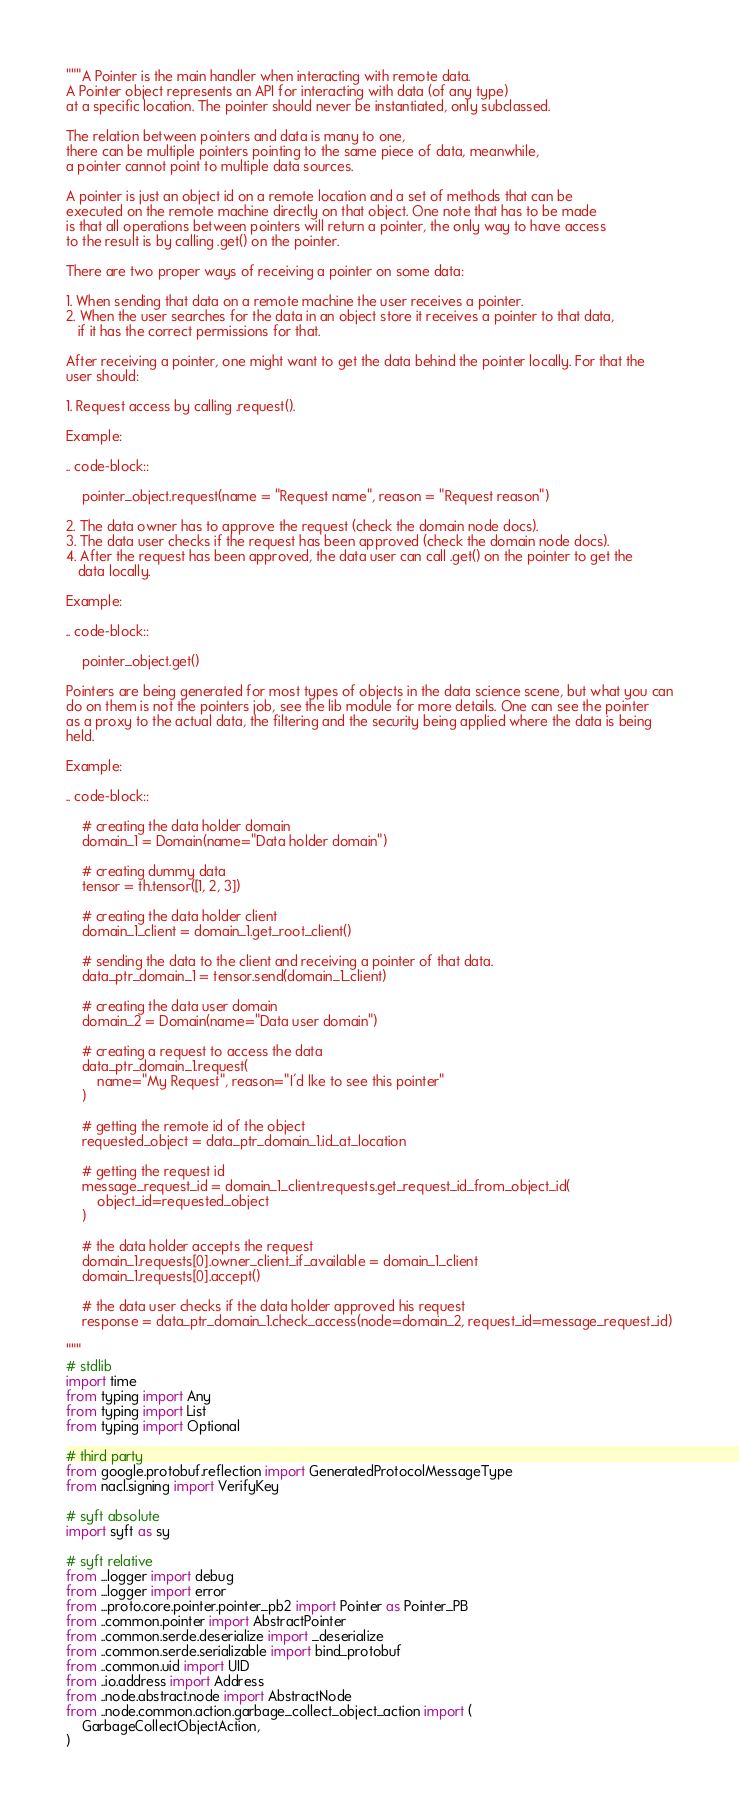<code> <loc_0><loc_0><loc_500><loc_500><_Python_>"""A Pointer is the main handler when interacting with remote data.
A Pointer object represents an API for interacting with data (of any type)
at a specific location. The pointer should never be instantiated, only subclassed.

The relation between pointers and data is many to one,
there can be multiple pointers pointing to the same piece of data, meanwhile,
a pointer cannot point to multiple data sources.

A pointer is just an object id on a remote location and a set of methods that can be
executed on the remote machine directly on that object. One note that has to be made
is that all operations between pointers will return a pointer, the only way to have access
to the result is by calling .get() on the pointer.

There are two proper ways of receiving a pointer on some data:

1. When sending that data on a remote machine the user receives a pointer.
2. When the user searches for the data in an object store it receives a pointer to that data,
   if it has the correct permissions for that.

After receiving a pointer, one might want to get the data behind the pointer locally. For that the
user should:

1. Request access by calling .request().

Example:

.. code-block::

    pointer_object.request(name = "Request name", reason = "Request reason")

2. The data owner has to approve the request (check the domain node docs).
3. The data user checks if the request has been approved (check the domain node docs).
4. After the request has been approved, the data user can call .get() on the pointer to get the
   data locally.

Example:

.. code-block::

    pointer_object.get()

Pointers are being generated for most types of objects in the data science scene, but what you can
do on them is not the pointers job, see the lib module for more details. One can see the pointer
as a proxy to the actual data, the filtering and the security being applied where the data is being
held.

Example:

.. code-block::

    # creating the data holder domain
    domain_1 = Domain(name="Data holder domain")

    # creating dummy data
    tensor = th.tensor([1, 2, 3])

    # creating the data holder client
    domain_1_client = domain_1.get_root_client()

    # sending the data to the client and receiving a pointer of that data.
    data_ptr_domain_1 = tensor.send(domain_1_client)

    # creating the data user domain
    domain_2 = Domain(name="Data user domain")

    # creating a request to access the data
    data_ptr_domain_1.request(
        name="My Request", reason="I'd lke to see this pointer"
    )

    # getting the remote id of the object
    requested_object = data_ptr_domain_1.id_at_location

    # getting the request id
    message_request_id = domain_1_client.requests.get_request_id_from_object_id(
        object_id=requested_object
    )

    # the data holder accepts the request
    domain_1.requests[0].owner_client_if_available = domain_1_client
    domain_1.requests[0].accept()

    # the data user checks if the data holder approved his request
    response = data_ptr_domain_1.check_access(node=domain_2, request_id=message_request_id)

"""
# stdlib
import time
from typing import Any
from typing import List
from typing import Optional

# third party
from google.protobuf.reflection import GeneratedProtocolMessageType
from nacl.signing import VerifyKey

# syft absolute
import syft as sy

# syft relative
from ...logger import debug
from ...logger import error
from ...proto.core.pointer.pointer_pb2 import Pointer as Pointer_PB
from ..common.pointer import AbstractPointer
from ..common.serde.deserialize import _deserialize
from ..common.serde.serializable import bind_protobuf
from ..common.uid import UID
from ..io.address import Address
from ..node.abstract.node import AbstractNode
from ..node.common.action.garbage_collect_object_action import (
    GarbageCollectObjectAction,
)</code> 